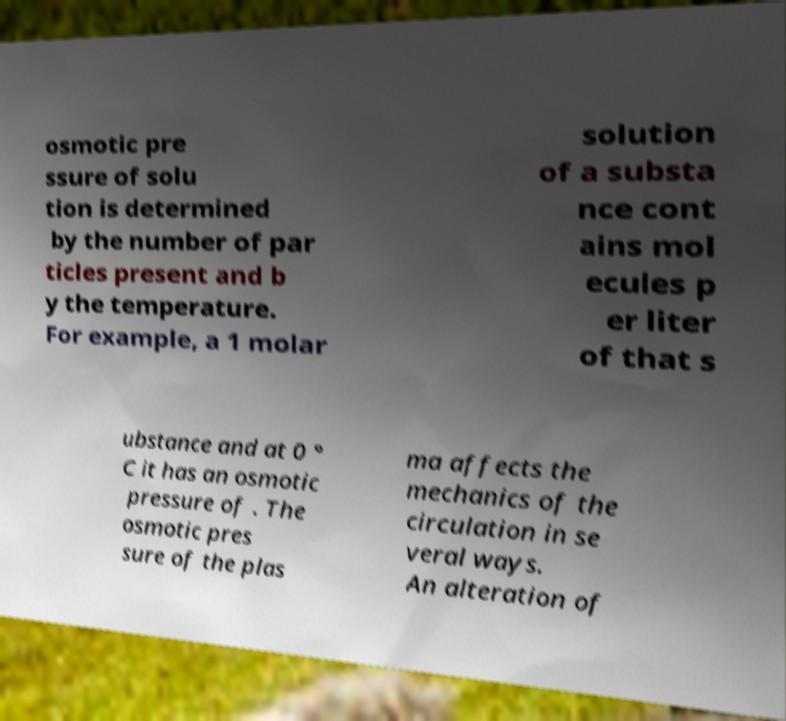There's text embedded in this image that I need extracted. Can you transcribe it verbatim? osmotic pre ssure of solu tion is determined by the number of par ticles present and b y the temperature. For example, a 1 molar solution of a substa nce cont ains mol ecules p er liter of that s ubstance and at 0 ° C it has an osmotic pressure of . The osmotic pres sure of the plas ma affects the mechanics of the circulation in se veral ways. An alteration of 